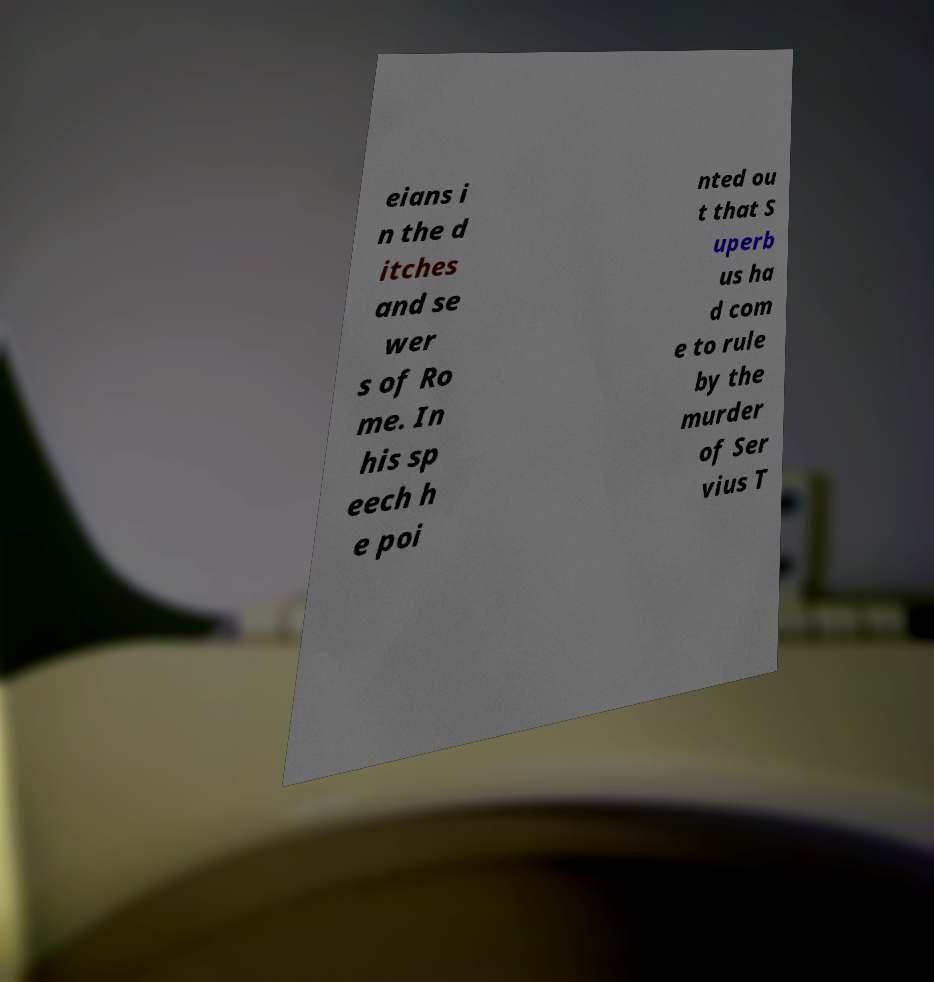What messages or text are displayed in this image? I need them in a readable, typed format. eians i n the d itches and se wer s of Ro me. In his sp eech h e poi nted ou t that S uperb us ha d com e to rule by the murder of Ser vius T 